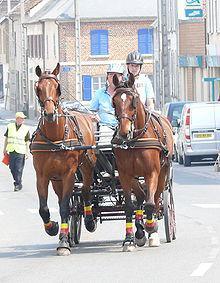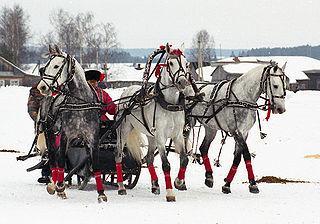The first image is the image on the left, the second image is the image on the right. Considering the images on both sides, is "In one image, there are a pair of horses drawing a carriage holding one person to the left." valid? Answer yes or no. No. The first image is the image on the left, the second image is the image on the right. For the images displayed, is the sentence "At least one of the horses is white." factually correct? Answer yes or no. Yes. 